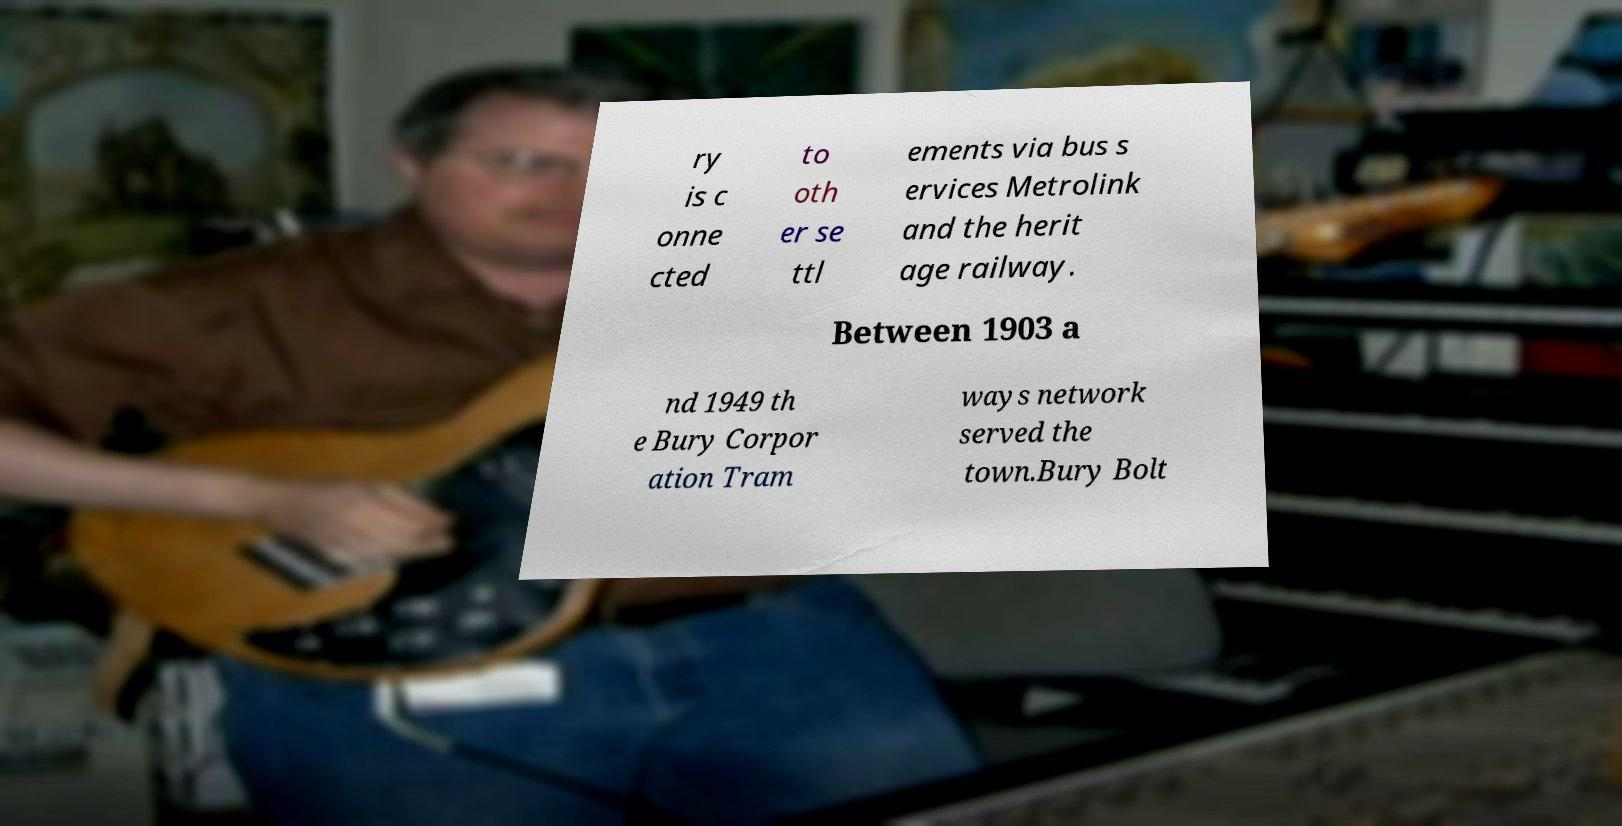Could you extract and type out the text from this image? ry is c onne cted to oth er se ttl ements via bus s ervices Metrolink and the herit age railway. Between 1903 a nd 1949 th e Bury Corpor ation Tram ways network served the town.Bury Bolt 